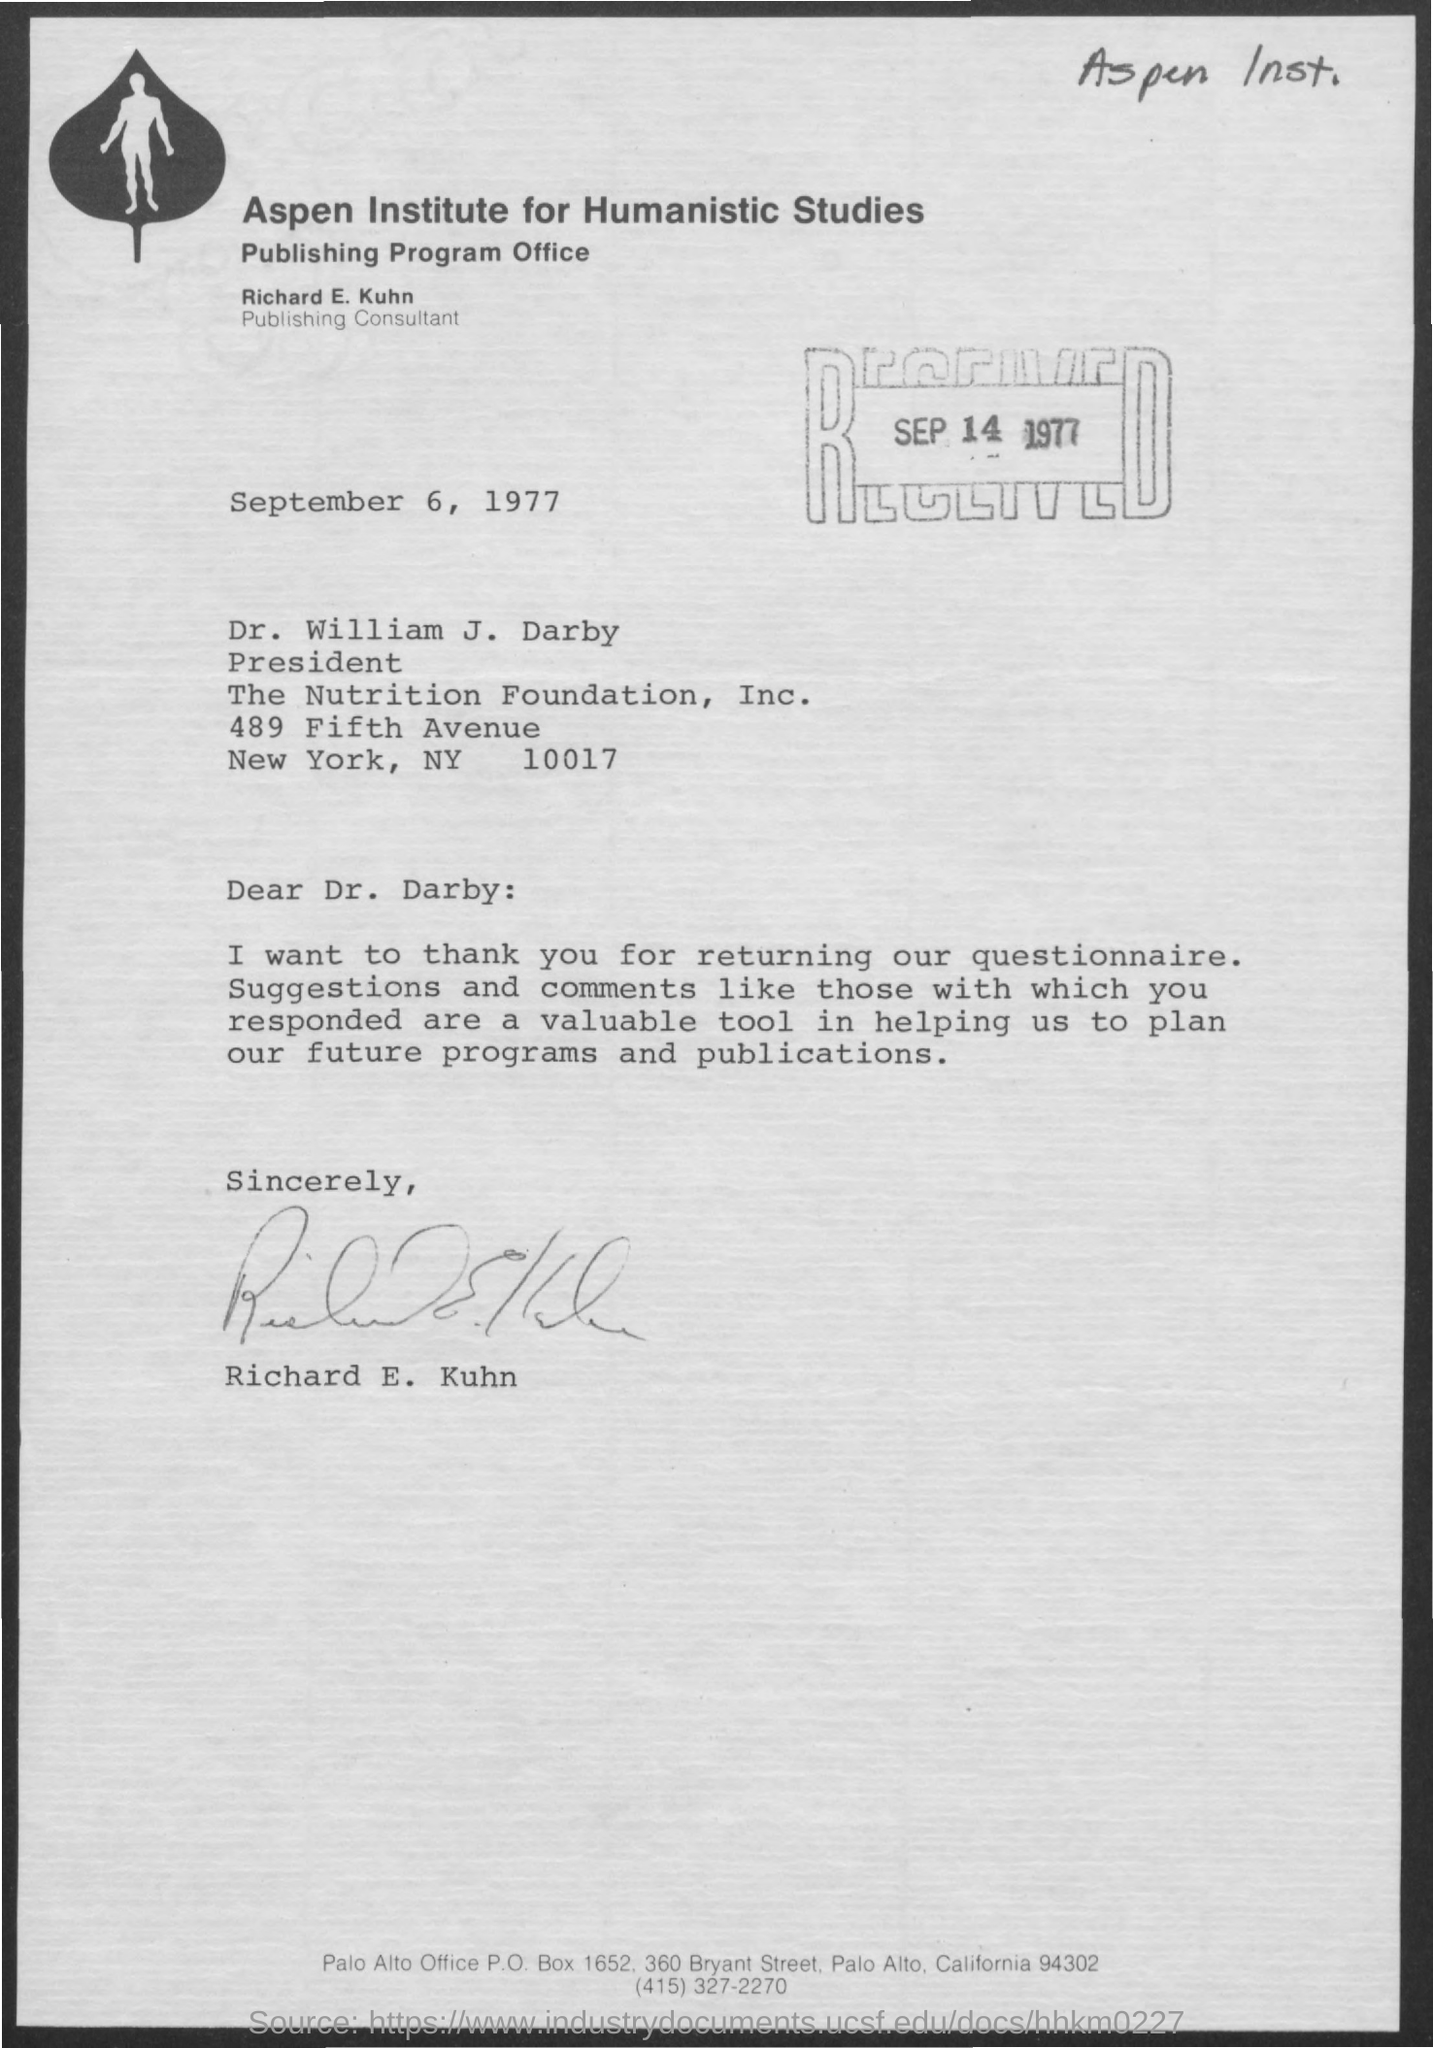What is the date of letter?
Offer a very short reply. September 6, 1977. What is designation of Richard E. Kuhn?
Your answer should be very brief. Publishing consultant. 